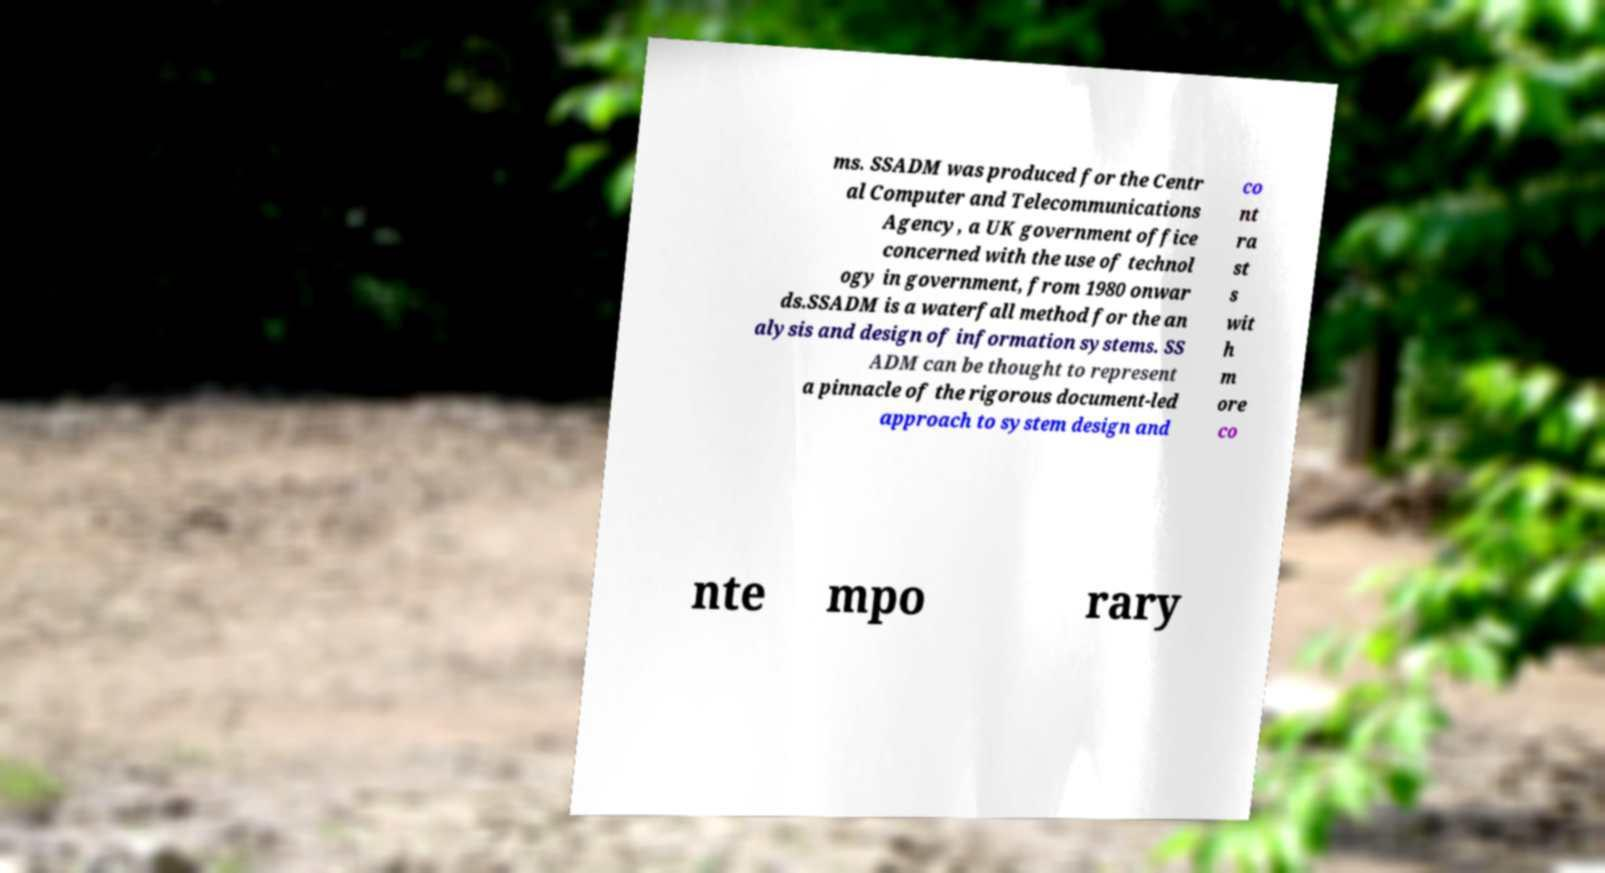Could you assist in decoding the text presented in this image and type it out clearly? ms. SSADM was produced for the Centr al Computer and Telecommunications Agency, a UK government office concerned with the use of technol ogy in government, from 1980 onwar ds.SSADM is a waterfall method for the an alysis and design of information systems. SS ADM can be thought to represent a pinnacle of the rigorous document-led approach to system design and co nt ra st s wit h m ore co nte mpo rary 